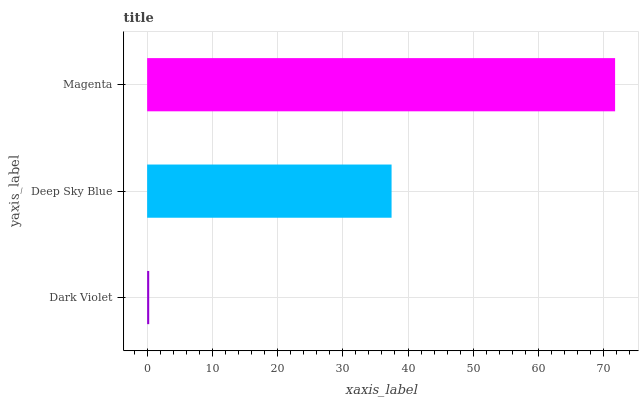Is Dark Violet the minimum?
Answer yes or no. Yes. Is Magenta the maximum?
Answer yes or no. Yes. Is Deep Sky Blue the minimum?
Answer yes or no. No. Is Deep Sky Blue the maximum?
Answer yes or no. No. Is Deep Sky Blue greater than Dark Violet?
Answer yes or no. Yes. Is Dark Violet less than Deep Sky Blue?
Answer yes or no. Yes. Is Dark Violet greater than Deep Sky Blue?
Answer yes or no. No. Is Deep Sky Blue less than Dark Violet?
Answer yes or no. No. Is Deep Sky Blue the high median?
Answer yes or no. Yes. Is Deep Sky Blue the low median?
Answer yes or no. Yes. Is Magenta the high median?
Answer yes or no. No. Is Magenta the low median?
Answer yes or no. No. 